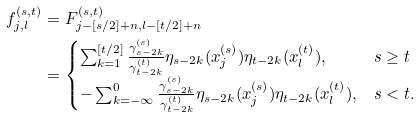Convert formula to latex. <formula><loc_0><loc_0><loc_500><loc_500>f _ { j , l } ^ { ( s , t ) } & = F ^ { ( s , t ) } _ { j - [ s / 2 ] + n , l - [ t / 2 ] + n } \\ & = \begin{cases} \sum _ { k = 1 } ^ { [ t / 2 ] } \frac { \gamma ^ { ( s ) } _ { s - 2 k } } { \gamma ^ { ( t ) } _ { t - 2 k } } \eta _ { s - 2 k } ( x _ { j } ^ { ( s ) } ) \eta _ { t - 2 k } ( x _ { l } ^ { ( t ) } ) , & s \geq t \\ - \sum _ { k = - \infty } ^ { 0 } \frac { \gamma ^ { ( s ) } _ { s - 2 k } } { \gamma ^ { ( t ) } _ { t - 2 k } } \eta _ { s - 2 k } ( x _ { j } ^ { ( s ) } ) \eta _ { t - 2 k } ( x _ { l } ^ { ( t ) } ) , & s < t . \end{cases}</formula> 